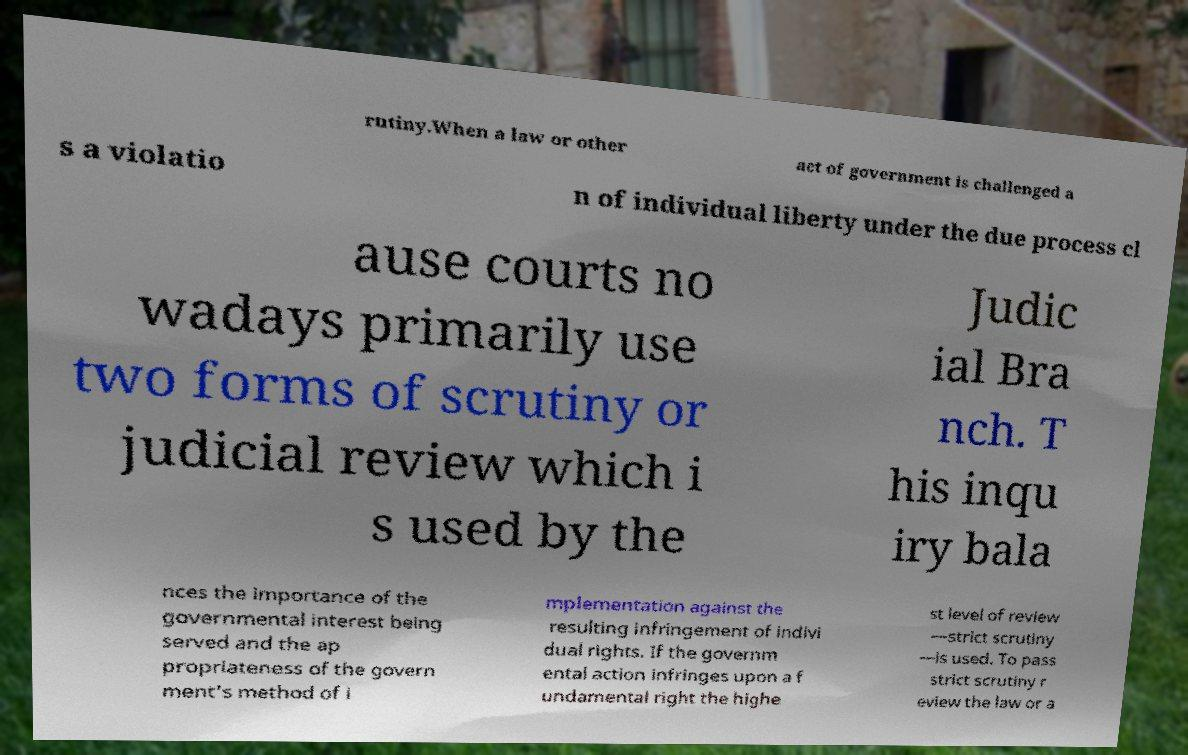Can you accurately transcribe the text from the provided image for me? rutiny.When a law or other act of government is challenged a s a violatio n of individual liberty under the due process cl ause courts no wadays primarily use two forms of scrutiny or judicial review which i s used by the Judic ial Bra nch. T his inqu iry bala nces the importance of the governmental interest being served and the ap propriateness of the govern ment's method of i mplementation against the resulting infringement of indivi dual rights. If the governm ental action infringes upon a f undamental right the highe st level of review —strict scrutiny —is used. To pass strict scrutiny r eview the law or a 